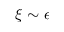Convert formula to latex. <formula><loc_0><loc_0><loc_500><loc_500>\xi \sim \epsilon</formula> 